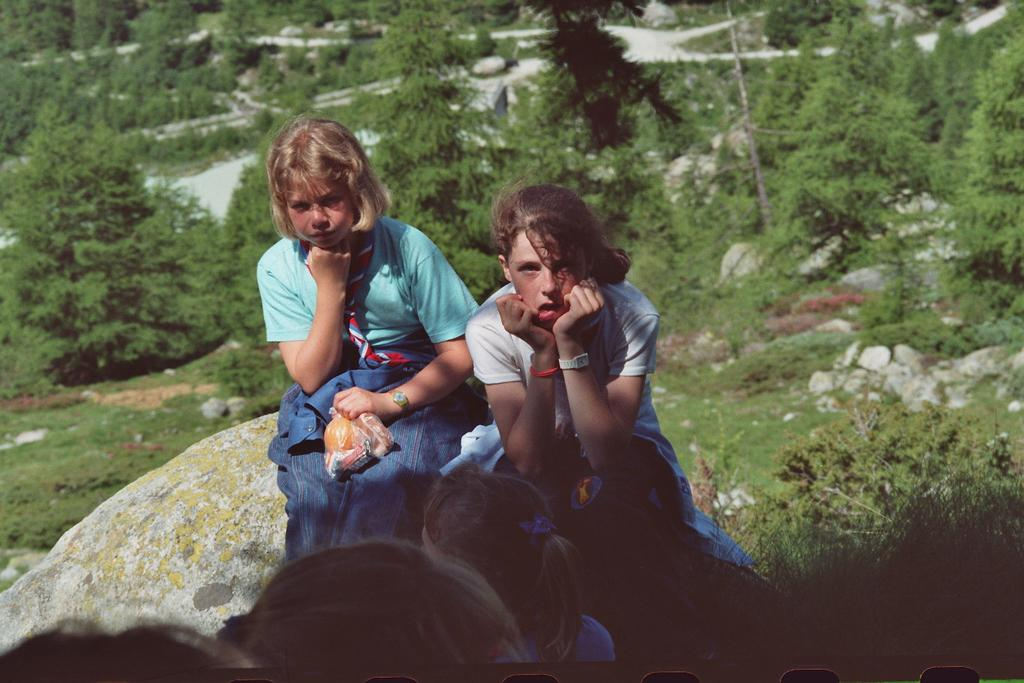What are the people in the image doing? The people in the image are sitting and watching something. What can be seen behind the people? There are trees and grass behind the people. Are there any natural elements in the image? Yes, there are stones and rocks in the image. Can you tell me how many boats are visible in the image? There are no boats present in the image. What type of property can be seen in the background of the image? There is no specific property mentioned or visible in the image; it only shows people, trees, grass, and stones. 